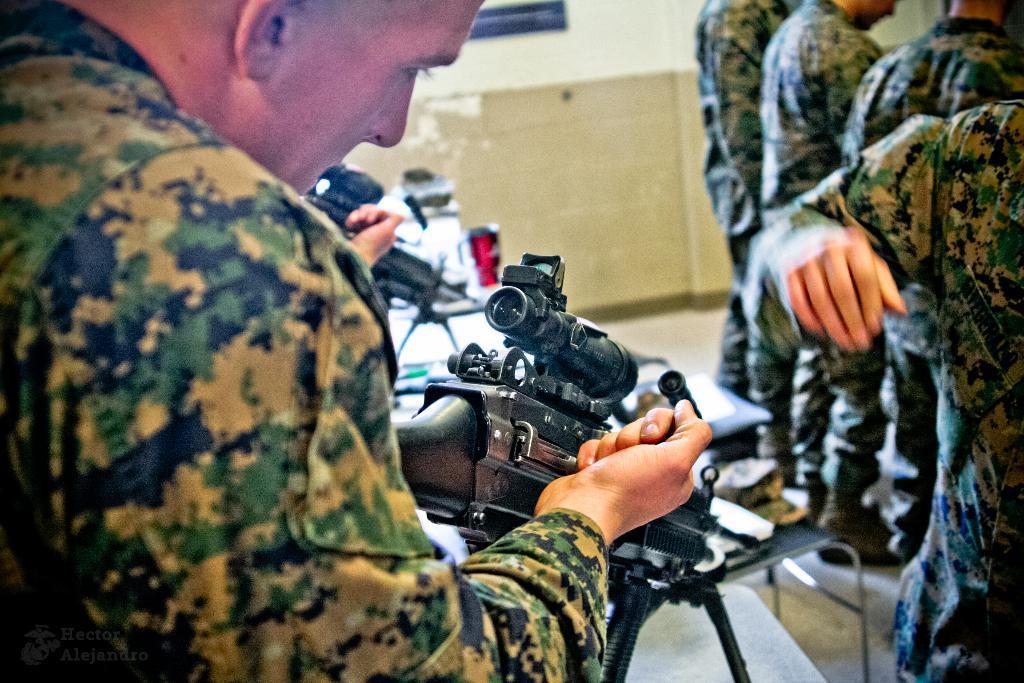Please provide a concise description of this image. In this picture we can see some people standing here, a man in the front is looking at a gun, in the background there is a wall, we can see one more gun here. 